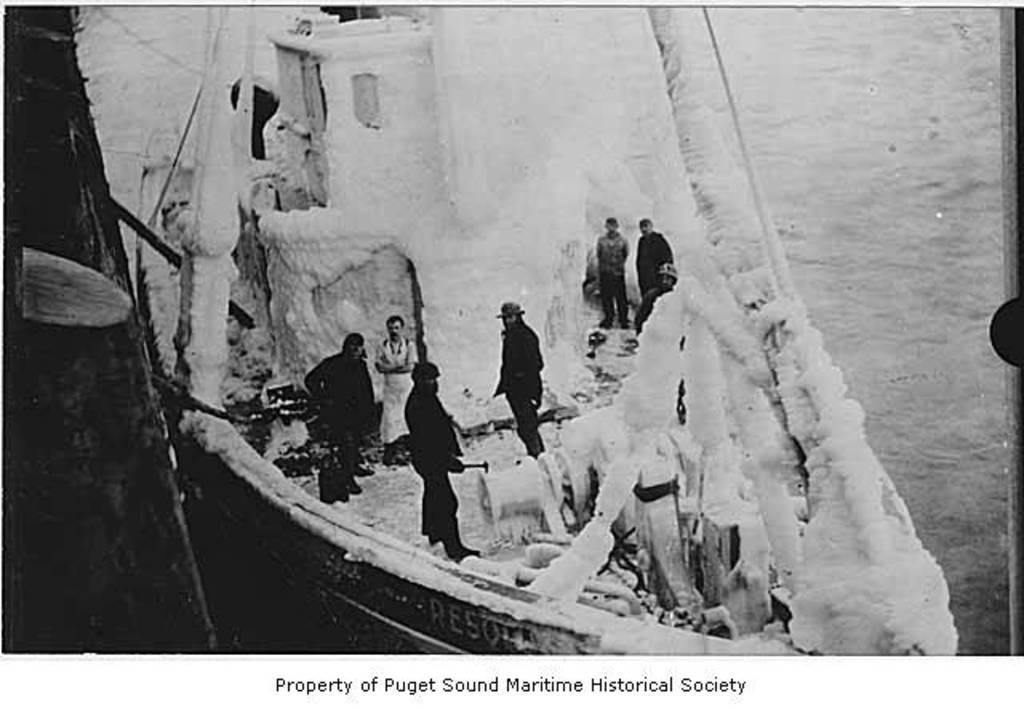In one or two sentences, can you explain what this image depicts? In this picture we can see few persons on the boat and there is water. At the bottom we can see text written on it. 